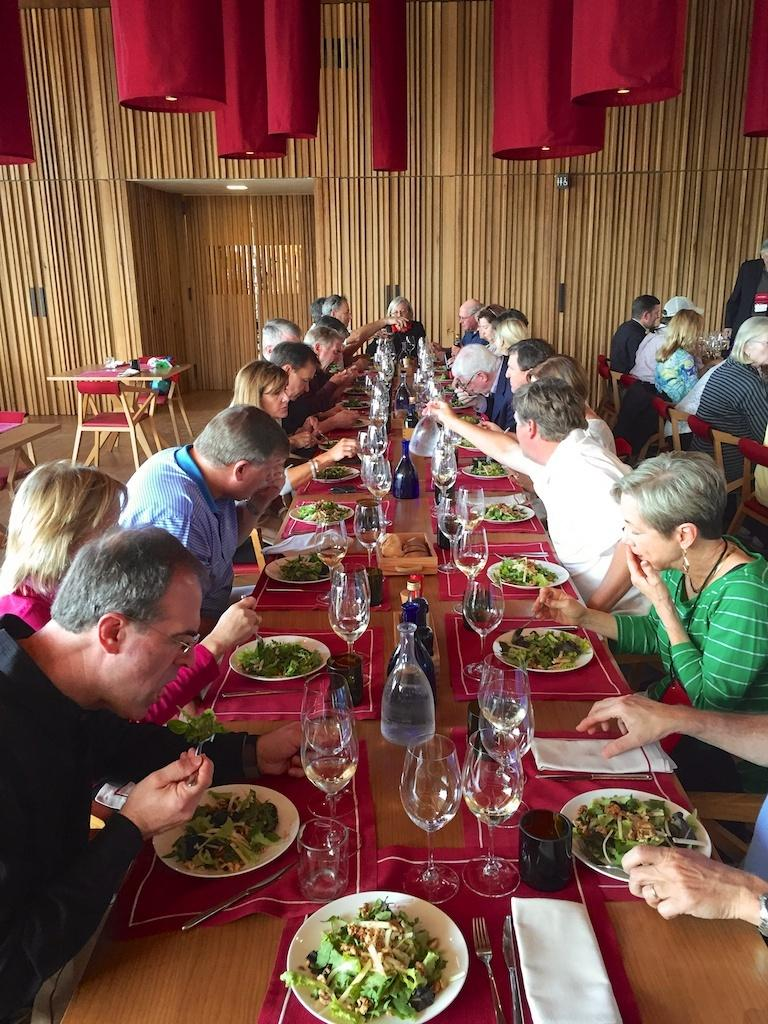How many people are in the image? There is a group of people in the image, but the exact number cannot be determined from the provided facts. What are the people doing in the image? The people are sitting in front of a table. What can be found on the table in the image? There are eatables and a glass of wine on the table. What type of root can be seen growing from the glass of wine in the image? There is no root growing from the glass of wine in the image. 